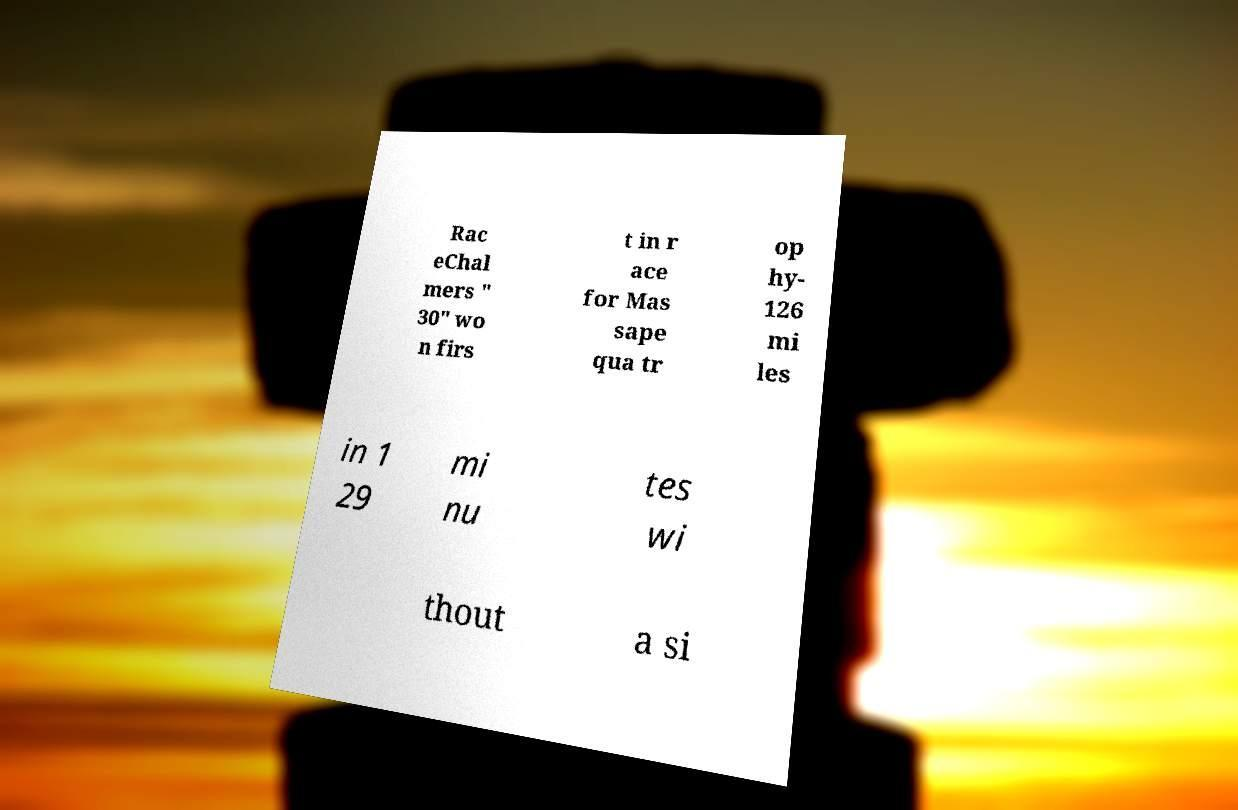Please identify and transcribe the text found in this image. Rac eChal mers " 30" wo n firs t in r ace for Mas sape qua tr op hy- 126 mi les in 1 29 mi nu tes wi thout a si 